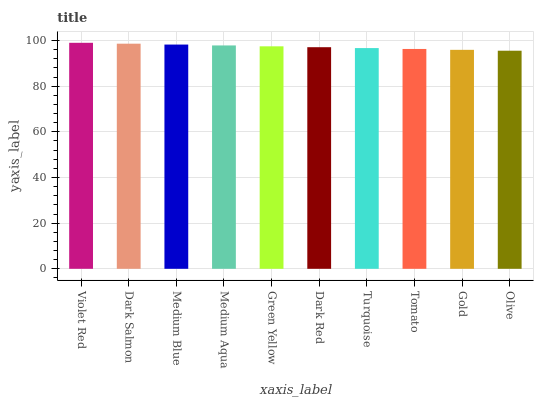Is Olive the minimum?
Answer yes or no. Yes. Is Violet Red the maximum?
Answer yes or no. Yes. Is Dark Salmon the minimum?
Answer yes or no. No. Is Dark Salmon the maximum?
Answer yes or no. No. Is Violet Red greater than Dark Salmon?
Answer yes or no. Yes. Is Dark Salmon less than Violet Red?
Answer yes or no. Yes. Is Dark Salmon greater than Violet Red?
Answer yes or no. No. Is Violet Red less than Dark Salmon?
Answer yes or no. No. Is Green Yellow the high median?
Answer yes or no. Yes. Is Dark Red the low median?
Answer yes or no. Yes. Is Medium Aqua the high median?
Answer yes or no. No. Is Medium Blue the low median?
Answer yes or no. No. 